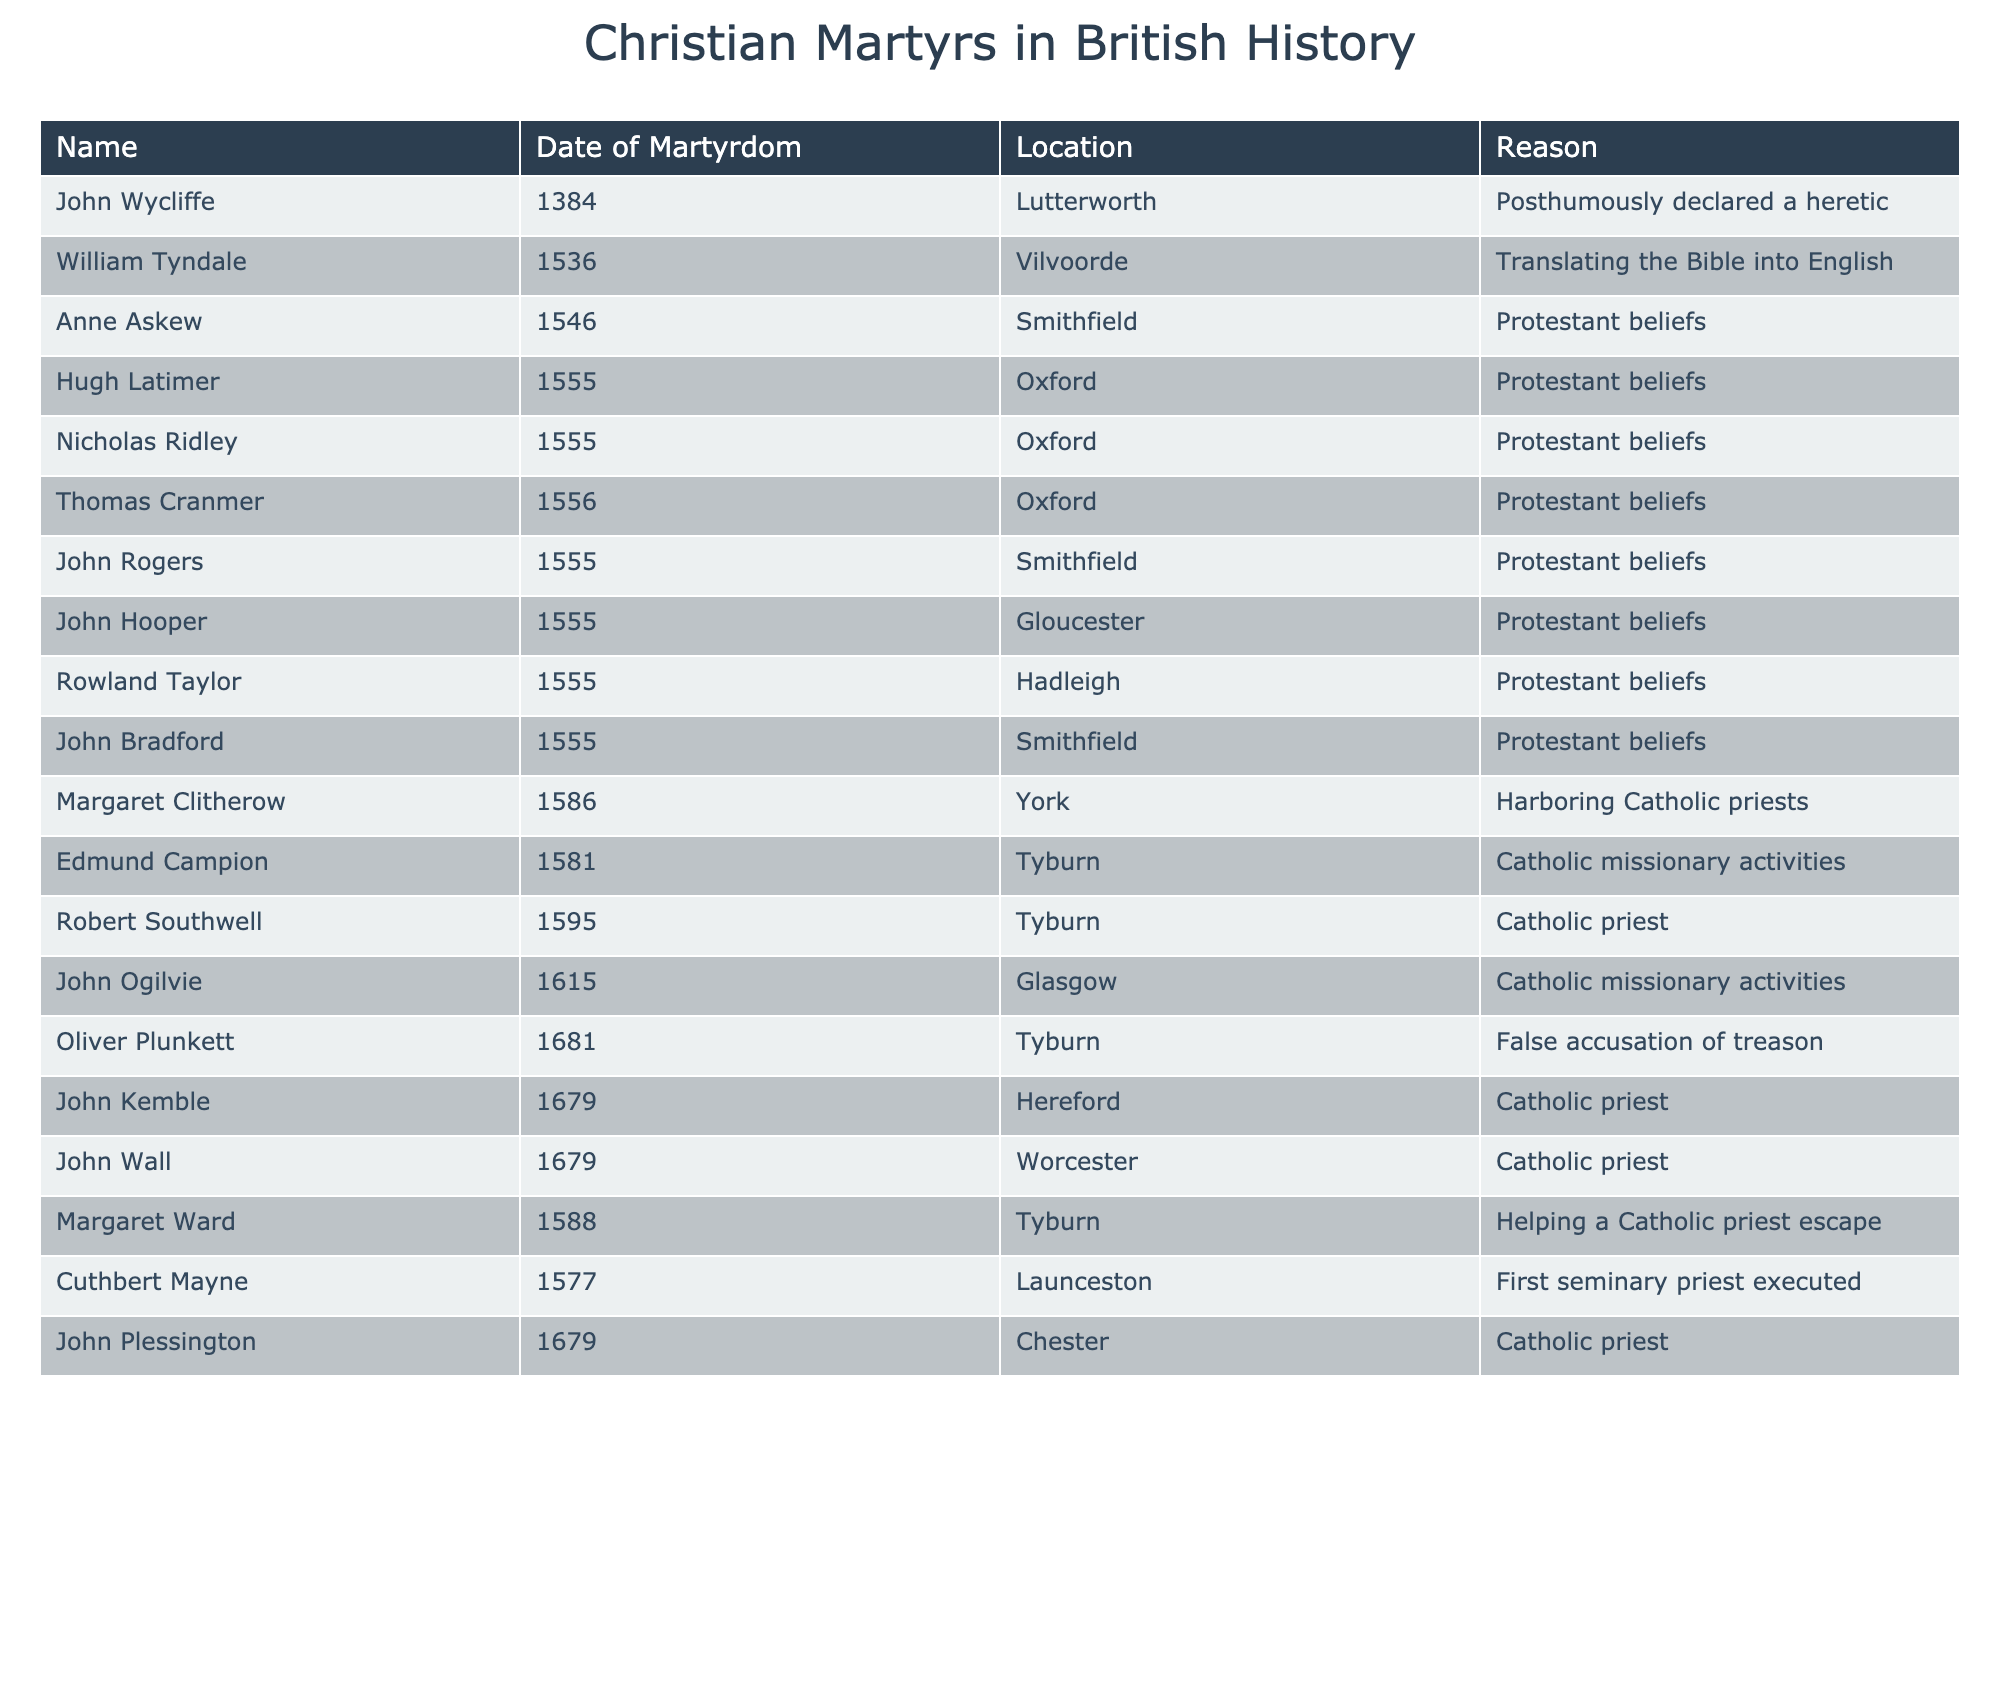What is the date of martyrdom for John Wycliffe? John Wycliffe is listed in the table under the "Name" column, and the corresponding date in the "Date of Martyrdom" column is provided in the same row. He was martyred in 1384.
Answer: 1384 How many martyrs were executed in Oxford? To find this, I count the entries in the table where the "Location" column is listed as "Oxford." There are three names mentioned: Hugh Latimer, Nicholas Ridley, and Thomas Cranmer. Therefore, the total count is three.
Answer: 3 Who was the first seminary priest executed? The table specifies Cuthbert Mayne as the first seminary priest executed under the "Name" column, with a corresponding entry in the "Reason" column identifying this fact.
Answer: Cuthbert Mayne Did any martyrs have the reason related to harboring priests? By checking the "Reason" column, I find that Margaret Clitherow, who is listed in the table, was martyred for harboring Catholic priests, indicating that the statement holds true.
Answer: Yes What is the average year of martyrdom for the listed martyrs? To calculate the average year, I sum up all the years of martyrdom from the "Date of Martyrdom" column: 1384 + 1536 + 1546 + 1555 + 1555 + 1556 + 1555 + 1555 + 1555 + 1586 + 1581 + 1595 + 1615 + 1681 + 1679 + 1679 + 1588 + 1577 + 1679 = 25053. Then I divide this sum (25053) by the total number of martyrs (17), which gives an average of approximately 1473.71.
Answer: 1473.71 How many martyrs were executed in Tyburn? In the table, I look for entries with "Tyburn" in the "Location" column. The names associated with Tyburn are Edmund Campion, Robert Southwell, and Oliver Plunkett, making a total of three martyrs executed there.
Answer: 3 Which martyr was accused of treason? The entry for Oliver Plunkett includes a note that he was martyred due to a false accusation of treason in the "Reason" column, so he is the martyr associated with this circumstance.
Answer: Oliver Plunkett How many martyrs were executed for Protestant beliefs? By examining the "Reason" column, I list the martyrs who were executed for Protestant beliefs: Anne Askew, Hugh Latimer, Nicholas Ridley, Thomas Cranmer, John Rogers, John Hooper, Rowland Taylor, John Bradford. This totals to eight martyrs.
Answer: 8 Was there a martyr named John who was executed in 1679? In the table, I find two names: John Kemble and John Wall, both executed in the year 1679. Since there are entries for John in different contexts, the statement holds true as there were at least two martyrs with that name executed in that year.
Answer: Yes 